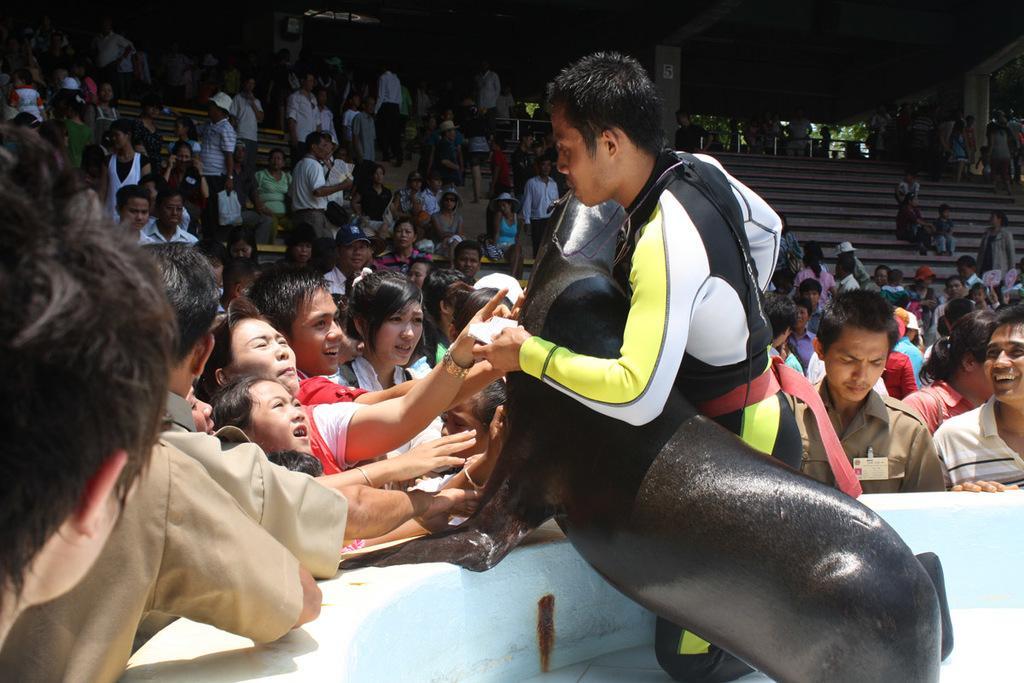Can you describe this image briefly? In the middle a man is standing by holding the black color object. On the left side few people are standing and talking with him. In the middle few persons are sitting on the staircase. 